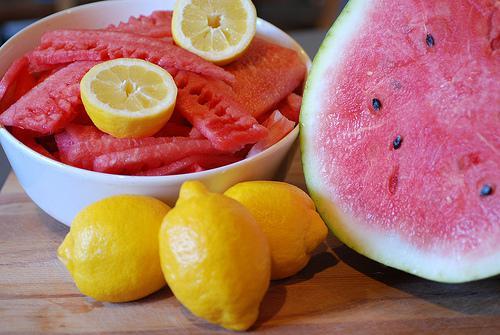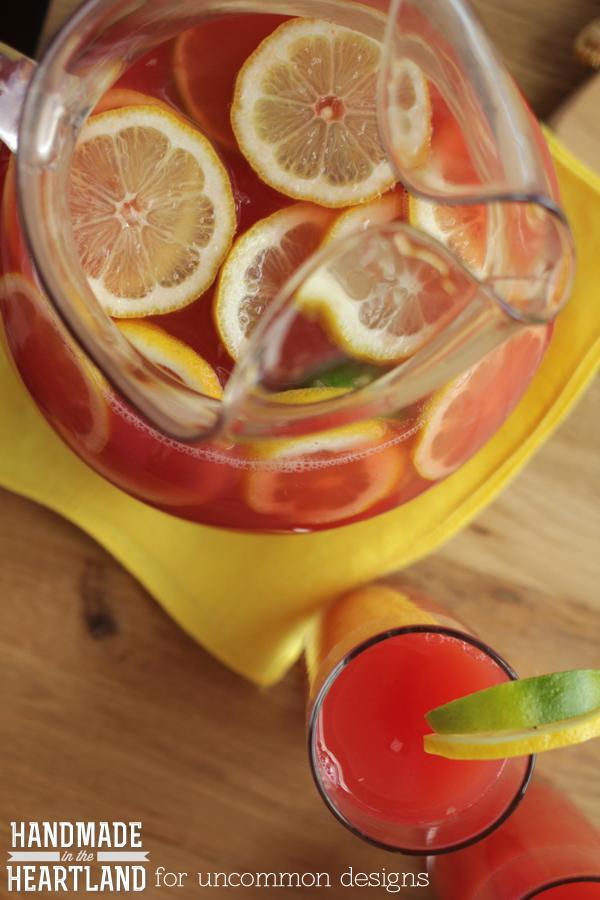The first image is the image on the left, the second image is the image on the right. For the images shown, is this caption "An image includes a serving pitcher and a garnished drink." true? Answer yes or no. Yes. The first image is the image on the left, the second image is the image on the right. Assess this claim about the two images: "There are three whole lemons in one of the images.". Correct or not? Answer yes or no. Yes. 